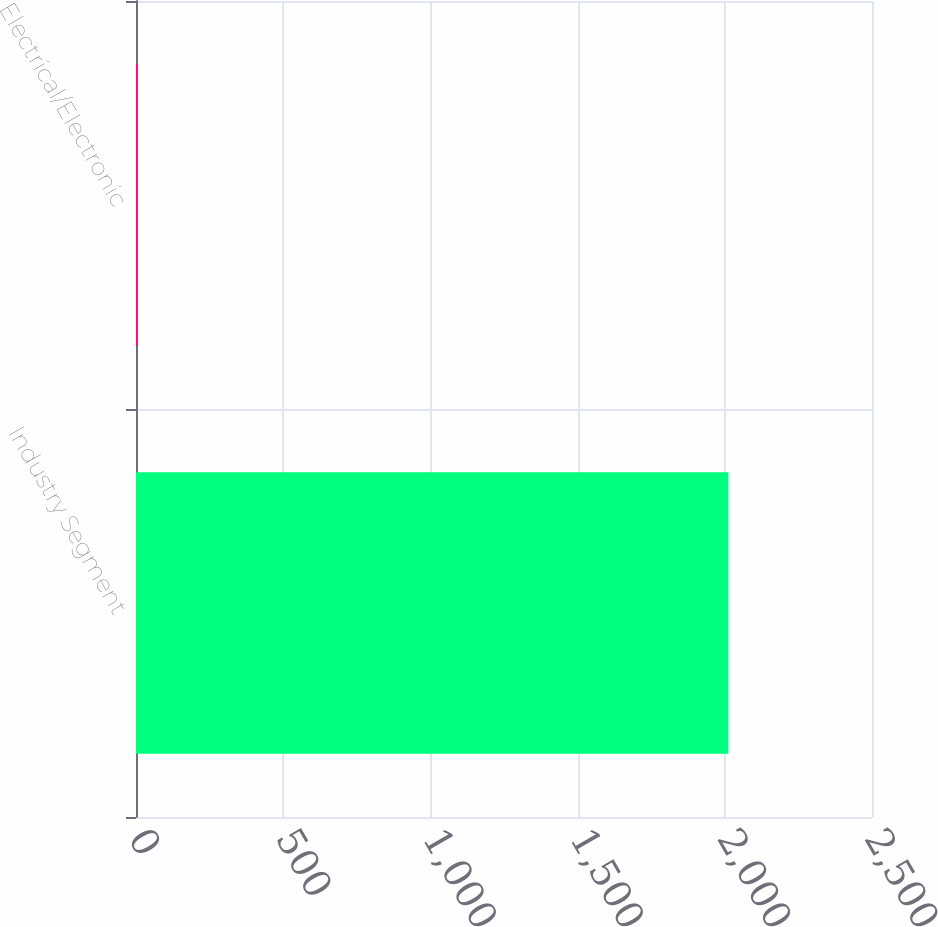<chart> <loc_0><loc_0><loc_500><loc_500><bar_chart><fcel>Industry Segment<fcel>Electrical/Electronic<nl><fcel>2012<fcel>4<nl></chart> 